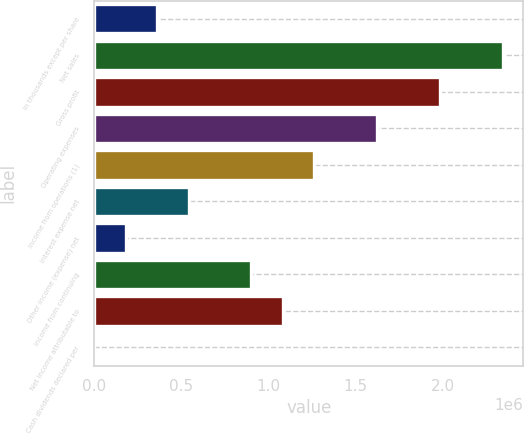<chart> <loc_0><loc_0><loc_500><loc_500><bar_chart><fcel>In thousands except per share<fcel>Net sales<fcel>Gross profit<fcel>Operating expenses<fcel>Income from operations (1)<fcel>Interest expense net<fcel>Other income (expense) net<fcel>Income from continuing<fcel>Net income attributable to<fcel>Cash dividends declared per<nl><fcel>360616<fcel>2.34401e+06<fcel>1.98339e+06<fcel>1.62277e+06<fcel>1.26216e+06<fcel>540924<fcel>180308<fcel>901541<fcel>1.08185e+06<fcel>0.04<nl></chart> 